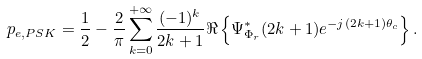Convert formula to latex. <formula><loc_0><loc_0><loc_500><loc_500>p _ { e , P S K } = \frac { 1 } { 2 } - \frac { 2 } { \pi } \sum _ { k = 0 } ^ { + \infty } \frac { ( - 1 ) ^ { k } } { 2 k + 1 } \Re \left \{ \Psi ^ { * } _ { \Phi _ { r } } ( 2 k + 1 ) e ^ { - j ( 2 k + 1 ) \theta _ { c } } \right \} .</formula> 